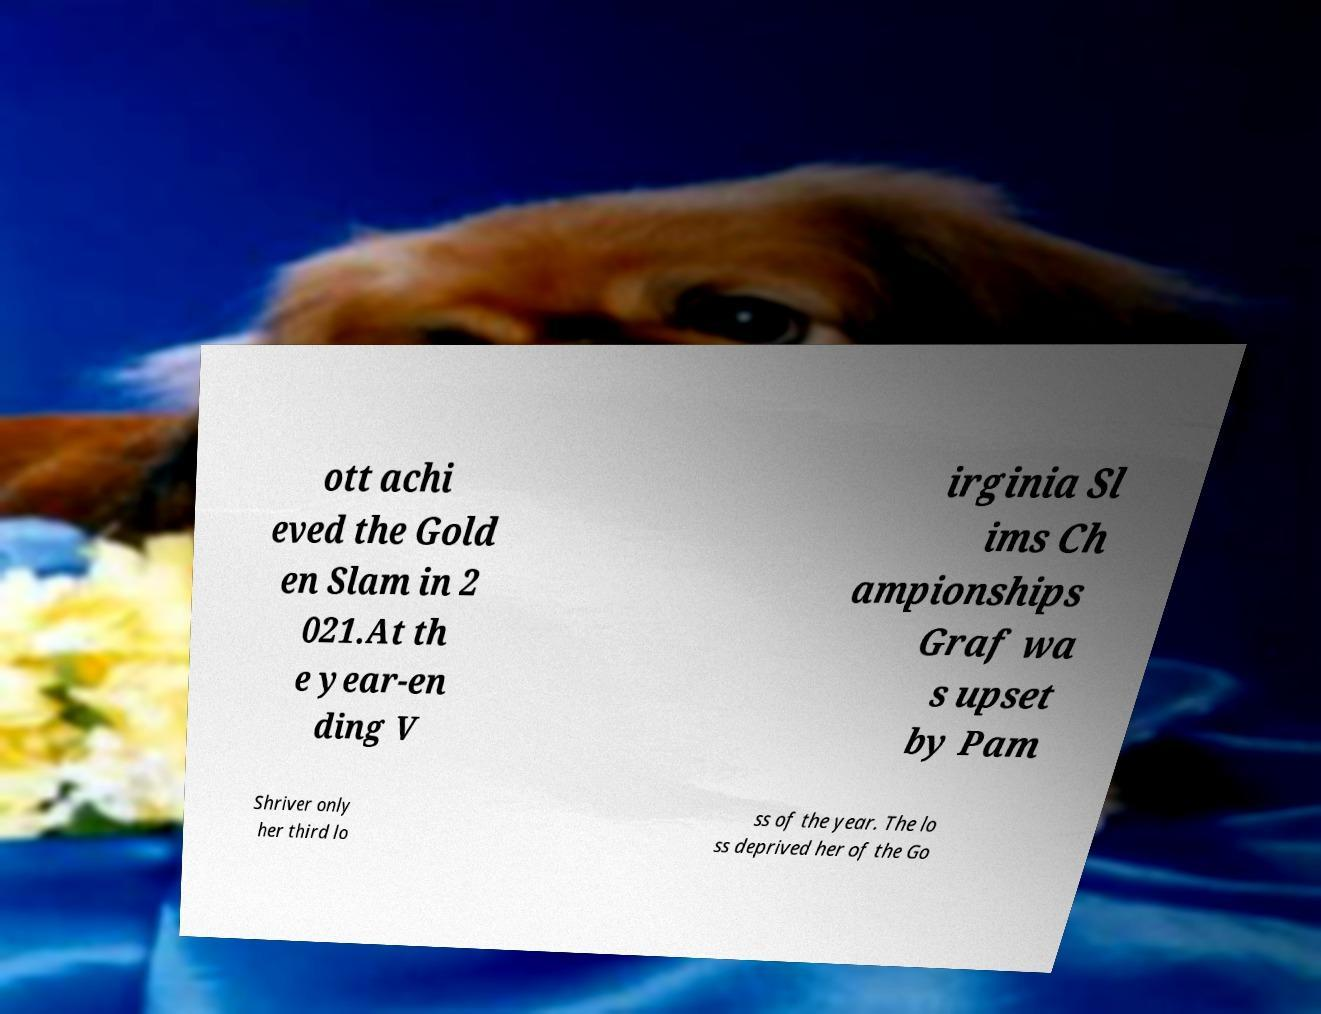Please read and relay the text visible in this image. What does it say? ott achi eved the Gold en Slam in 2 021.At th e year-en ding V irginia Sl ims Ch ampionships Graf wa s upset by Pam Shriver only her third lo ss of the year. The lo ss deprived her of the Go 